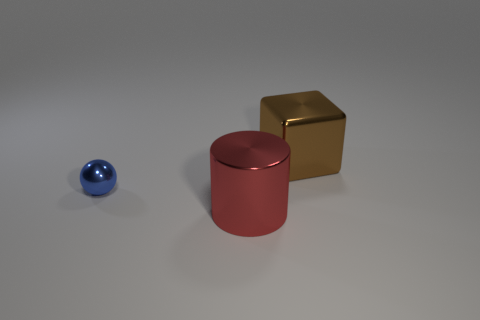Add 2 big brown blocks. How many objects exist? 5 Subtract all spheres. How many objects are left? 2 Subtract 1 cylinders. How many cylinders are left? 0 Add 2 big red cylinders. How many big red cylinders are left? 3 Add 3 large cubes. How many large cubes exist? 4 Subtract 1 red cylinders. How many objects are left? 2 Subtract all green balls. Subtract all green blocks. How many balls are left? 1 Subtract all large brown objects. Subtract all red cylinders. How many objects are left? 1 